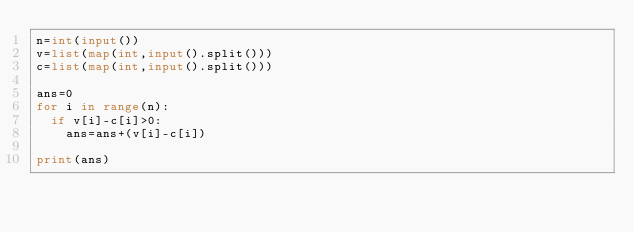<code> <loc_0><loc_0><loc_500><loc_500><_Python_>n=int(input())
v=list(map(int,input().split()))
c=list(map(int,input().split()))

ans=0
for i in range(n):
  if v[i]-c[i]>0:
    ans=ans+(v[i]-c[i])

print(ans)</code> 